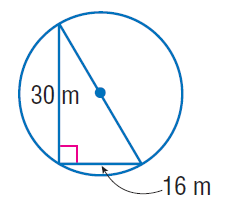Answer the mathemtical geometry problem and directly provide the correct option letter.
Question: Find the exact circumference of the circle.
Choices: A: 17 \pi B: 30 \pi C: 34 \pi D: 64 \pi C 